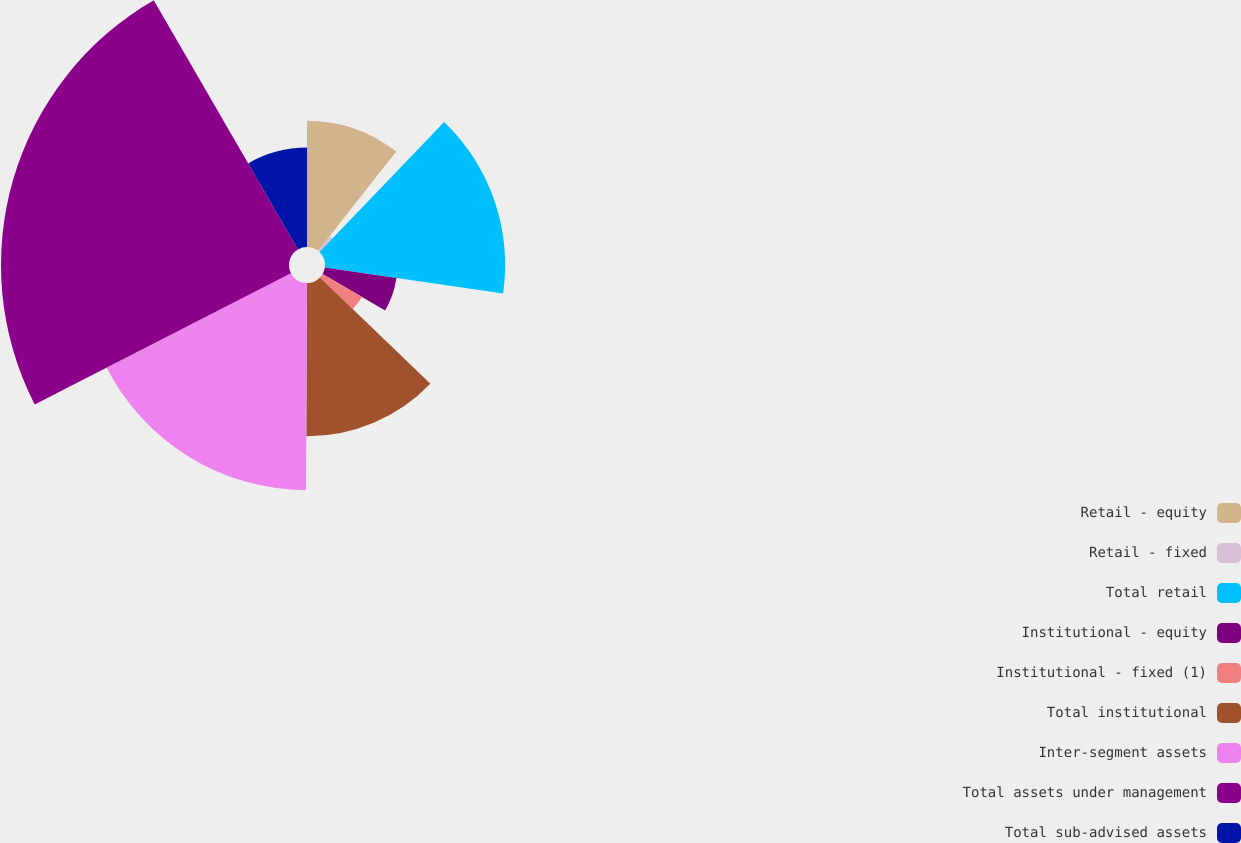<chart> <loc_0><loc_0><loc_500><loc_500><pie_chart><fcel>Retail - equity<fcel>Retail - fixed<fcel>Total retail<fcel>Institutional - equity<fcel>Institutional - fixed (1)<fcel>Total institutional<fcel>Inter-segment assets<fcel>Total assets under management<fcel>Total sub-advised assets<nl><fcel>10.61%<fcel>1.56%<fcel>15.13%<fcel>6.08%<fcel>3.82%<fcel>12.87%<fcel>17.4%<fcel>24.19%<fcel>8.35%<nl></chart> 